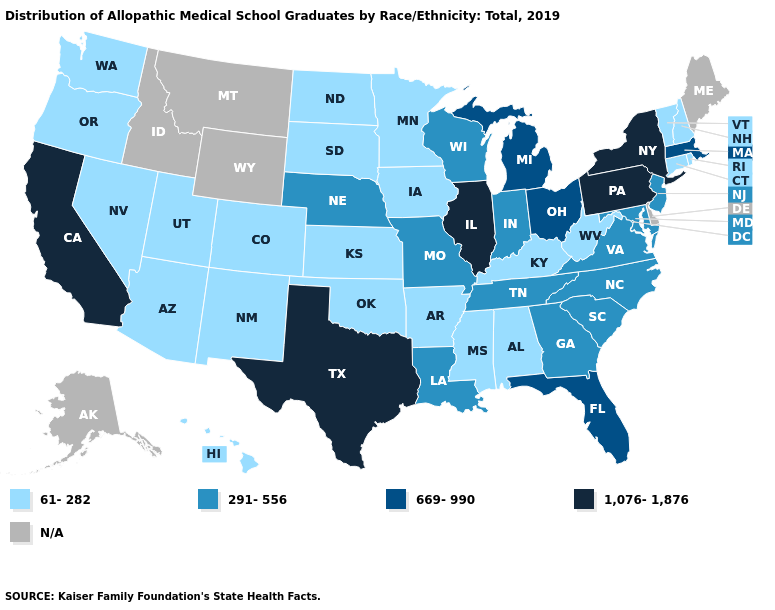Which states have the lowest value in the West?
Quick response, please. Arizona, Colorado, Hawaii, Nevada, New Mexico, Oregon, Utah, Washington. What is the highest value in the West ?
Write a very short answer. 1,076-1,876. Which states have the lowest value in the USA?
Be succinct. Alabama, Arizona, Arkansas, Colorado, Connecticut, Hawaii, Iowa, Kansas, Kentucky, Minnesota, Mississippi, Nevada, New Hampshire, New Mexico, North Dakota, Oklahoma, Oregon, Rhode Island, South Dakota, Utah, Vermont, Washington, West Virginia. Which states have the lowest value in the USA?
Write a very short answer. Alabama, Arizona, Arkansas, Colorado, Connecticut, Hawaii, Iowa, Kansas, Kentucky, Minnesota, Mississippi, Nevada, New Hampshire, New Mexico, North Dakota, Oklahoma, Oregon, Rhode Island, South Dakota, Utah, Vermont, Washington, West Virginia. Which states have the lowest value in the West?
Be succinct. Arizona, Colorado, Hawaii, Nevada, New Mexico, Oregon, Utah, Washington. Does Kentucky have the lowest value in the USA?
Short answer required. Yes. Name the states that have a value in the range 669-990?
Quick response, please. Florida, Massachusetts, Michigan, Ohio. Does the first symbol in the legend represent the smallest category?
Answer briefly. Yes. Which states hav the highest value in the Northeast?
Be succinct. New York, Pennsylvania. Which states have the lowest value in the USA?
Short answer required. Alabama, Arizona, Arkansas, Colorado, Connecticut, Hawaii, Iowa, Kansas, Kentucky, Minnesota, Mississippi, Nevada, New Hampshire, New Mexico, North Dakota, Oklahoma, Oregon, Rhode Island, South Dakota, Utah, Vermont, Washington, West Virginia. Name the states that have a value in the range 669-990?
Be succinct. Florida, Massachusetts, Michigan, Ohio. Among the states that border Delaware , which have the lowest value?
Concise answer only. Maryland, New Jersey. Among the states that border Missouri , does Nebraska have the lowest value?
Quick response, please. No. Among the states that border Indiana , which have the lowest value?
Short answer required. Kentucky. 